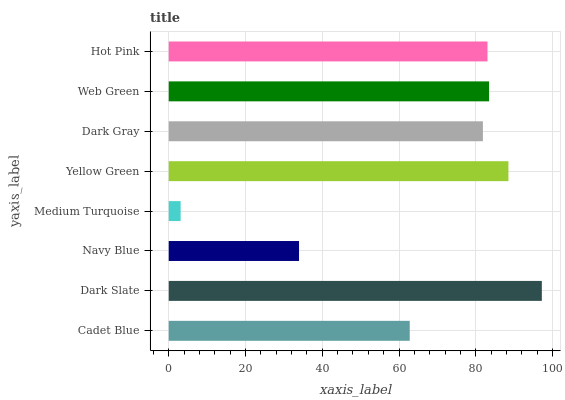Is Medium Turquoise the minimum?
Answer yes or no. Yes. Is Dark Slate the maximum?
Answer yes or no. Yes. Is Navy Blue the minimum?
Answer yes or no. No. Is Navy Blue the maximum?
Answer yes or no. No. Is Dark Slate greater than Navy Blue?
Answer yes or no. Yes. Is Navy Blue less than Dark Slate?
Answer yes or no. Yes. Is Navy Blue greater than Dark Slate?
Answer yes or no. No. Is Dark Slate less than Navy Blue?
Answer yes or no. No. Is Hot Pink the high median?
Answer yes or no. Yes. Is Dark Gray the low median?
Answer yes or no. Yes. Is Cadet Blue the high median?
Answer yes or no. No. Is Medium Turquoise the low median?
Answer yes or no. No. 